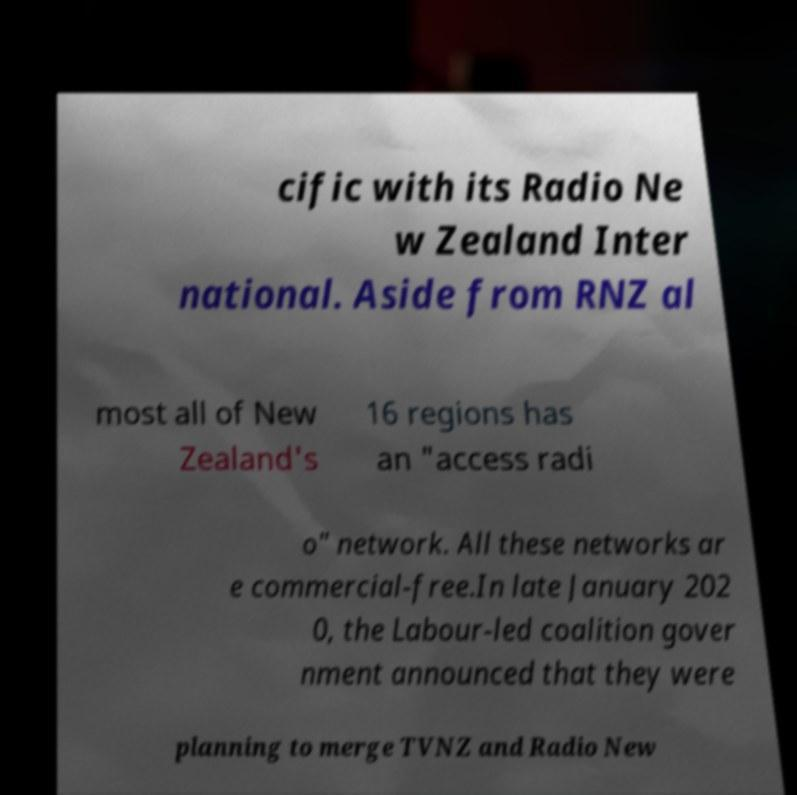Can you read and provide the text displayed in the image?This photo seems to have some interesting text. Can you extract and type it out for me? cific with its Radio Ne w Zealand Inter national. Aside from RNZ al most all of New Zealand's 16 regions has an "access radi o" network. All these networks ar e commercial-free.In late January 202 0, the Labour-led coalition gover nment announced that they were planning to merge TVNZ and Radio New 